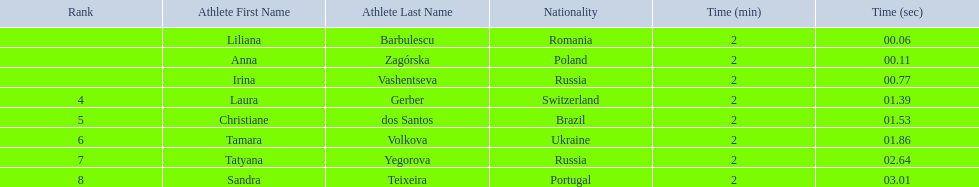Who were the athletes? Liliana Barbulescu, 2:00.06, Anna Zagórska, 2:00.11, Irina Vashentseva, 2:00.77, Laura Gerber, 2:01.39, Christiane dos Santos, 2:01.53, Tamara Volkova, 2:01.86, Tatyana Yegorova, 2:02.64, Sandra Teixeira, 2:03.01. Who received 2nd place? Anna Zagórska, 2:00.11. What was her time? 2:00.11. 